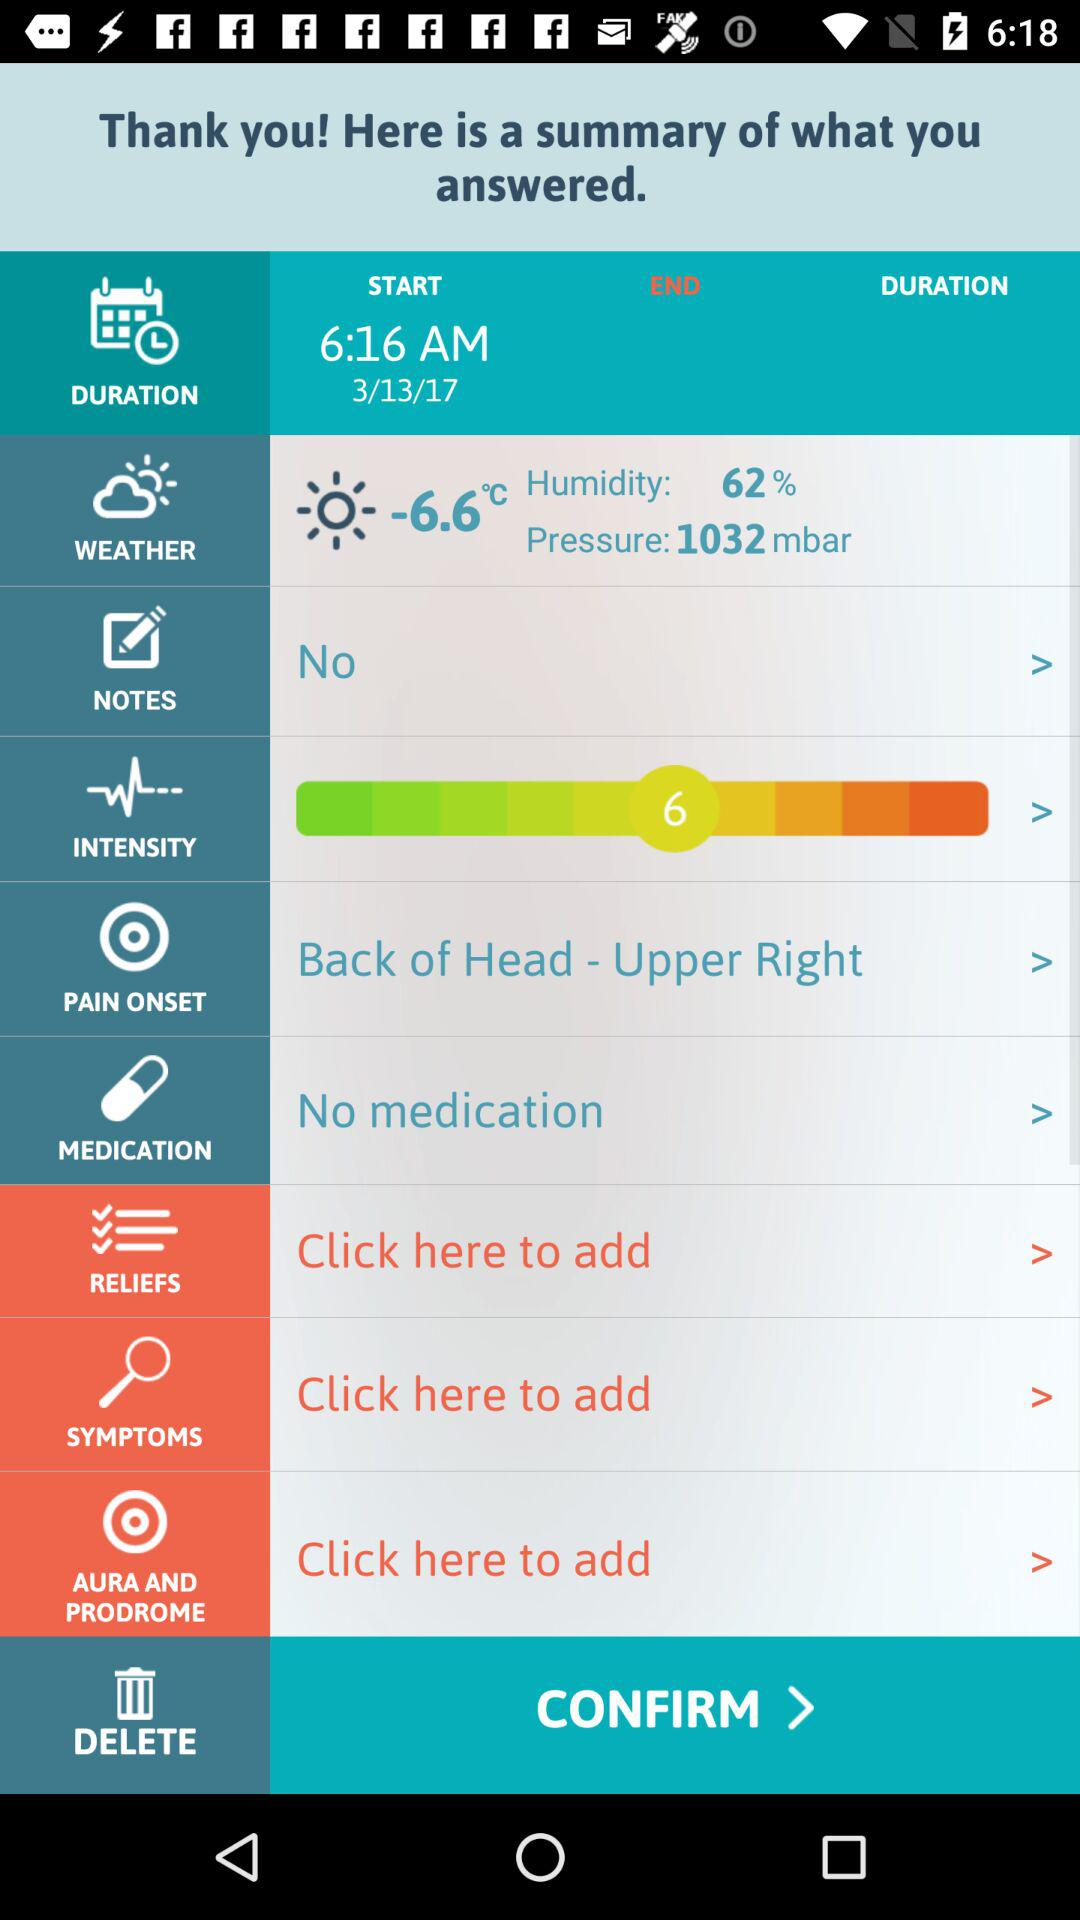What is the percentage of humidity? The percentage of humidity is 62. 